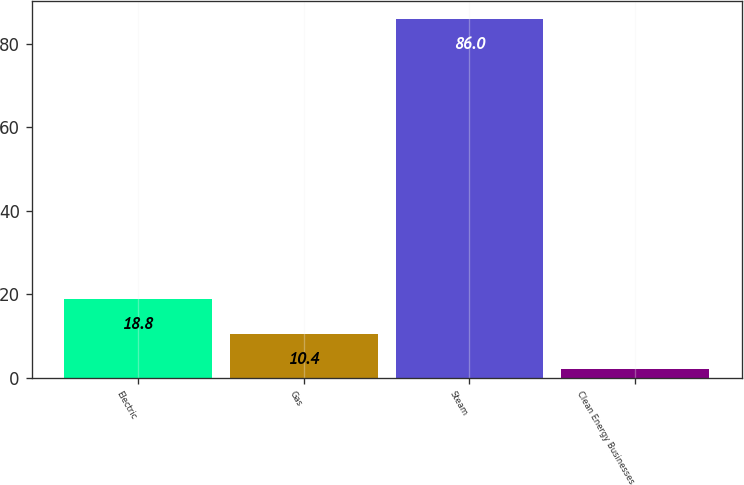Convert chart. <chart><loc_0><loc_0><loc_500><loc_500><bar_chart><fcel>Electric<fcel>Gas<fcel>Steam<fcel>Clean Energy Businesses<nl><fcel>18.8<fcel>10.4<fcel>86<fcel>2<nl></chart> 